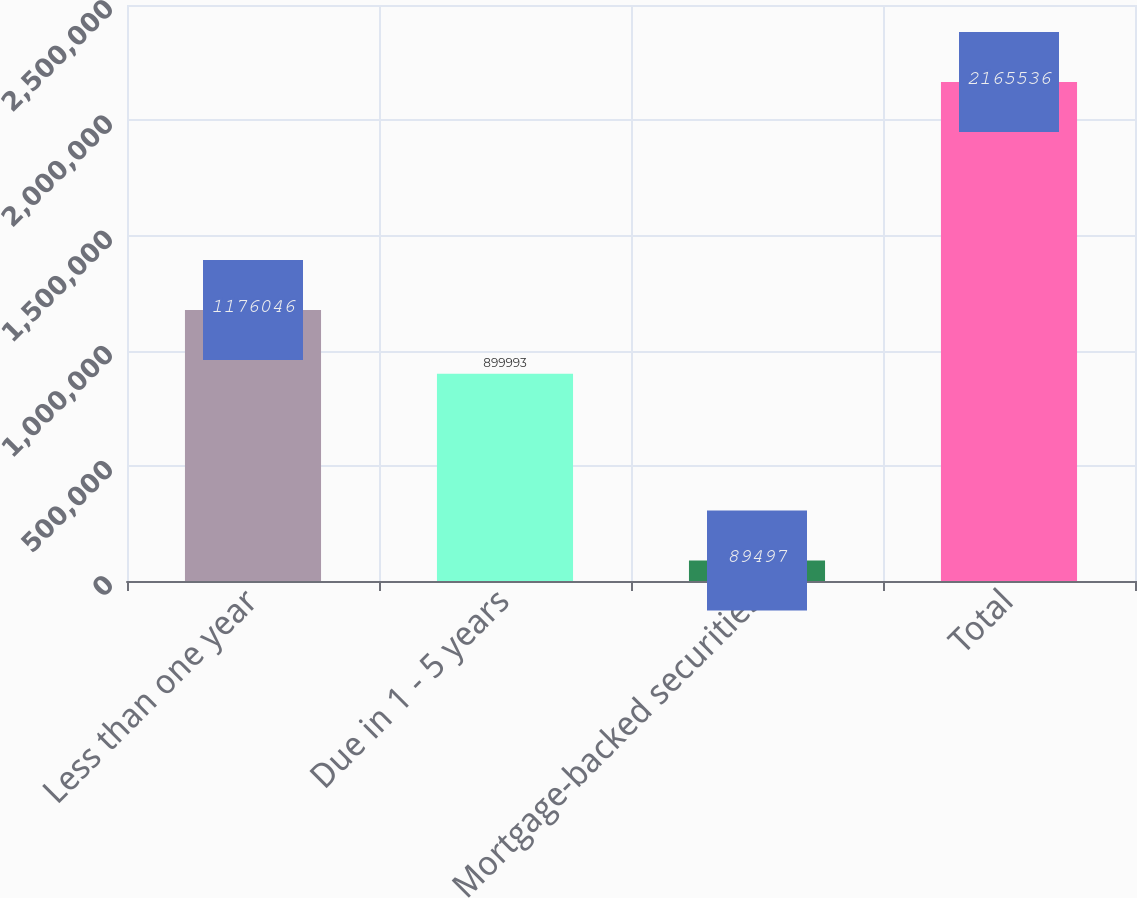Convert chart. <chart><loc_0><loc_0><loc_500><loc_500><bar_chart><fcel>Less than one year<fcel>Due in 1 - 5 years<fcel>Mortgage-backed securities<fcel>Total<nl><fcel>1.17605e+06<fcel>899993<fcel>89497<fcel>2.16554e+06<nl></chart> 